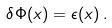<formula> <loc_0><loc_0><loc_500><loc_500>\delta \Phi ( x ) = \epsilon ( x ) \, .</formula> 